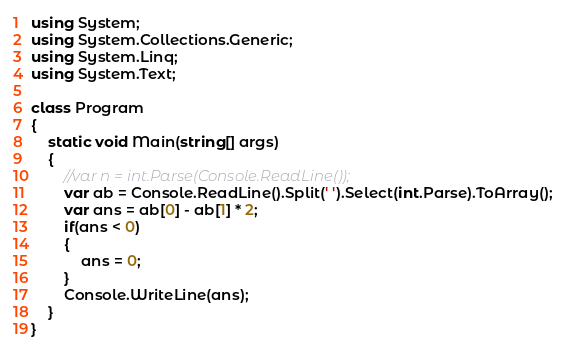Convert code to text. <code><loc_0><loc_0><loc_500><loc_500><_C#_>using System;
using System.Collections.Generic;
using System.Linq;
using System.Text;

class Program
{
    static void Main(string[] args)
    {
        //var n = int.Parse(Console.ReadLine());
        var ab = Console.ReadLine().Split(' ').Select(int.Parse).ToArray();
        var ans = ab[0] - ab[1] * 2;
        if(ans < 0)
        {
            ans = 0;
        }
        Console.WriteLine(ans);
    }
}</code> 